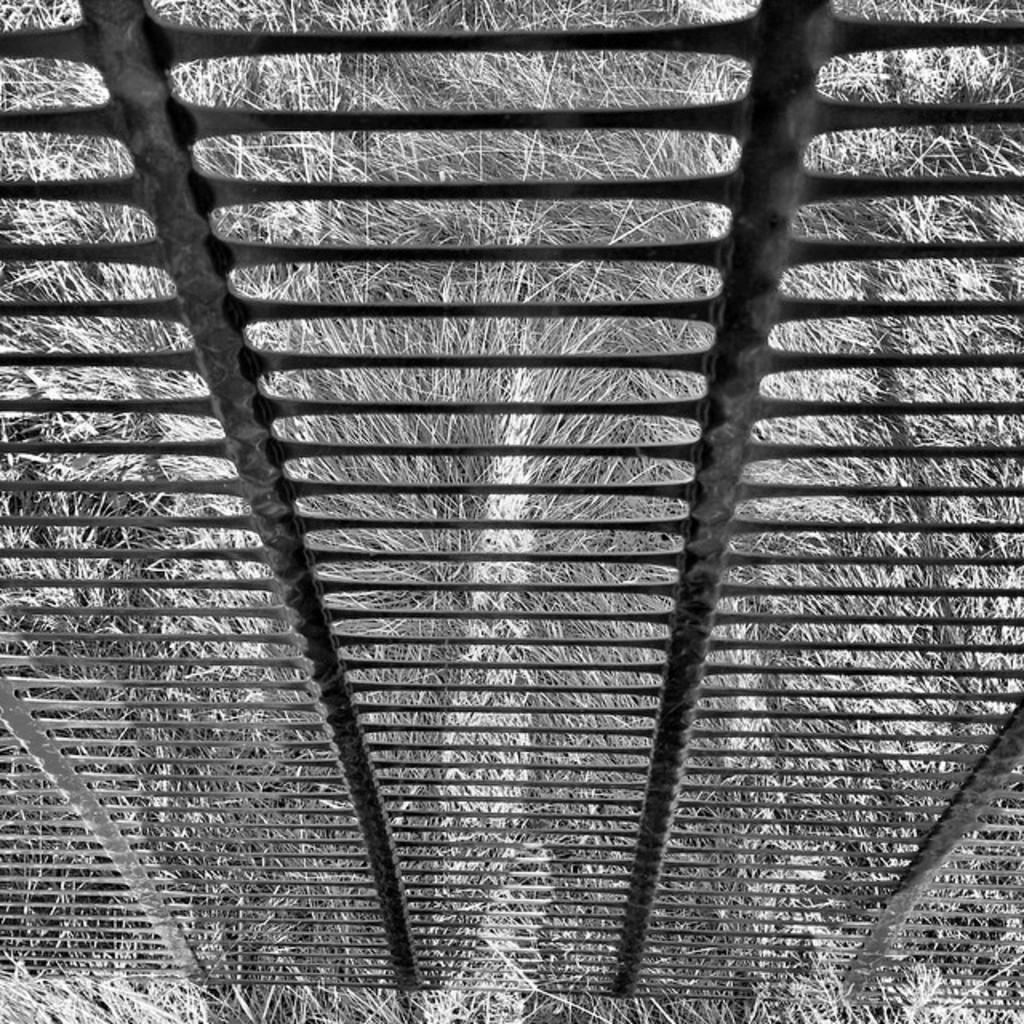What is present on the surface in the image? There is a railing on a dried grass surface in the image. Can you describe the railing in the image? The railing is the main subject visible in the image. How many lamps are present on the railing in the image? There are no lamps present on the railing in the image. What year is depicted in the image? The image does not depict a specific year; it only shows a railing on a dried grass surface. 